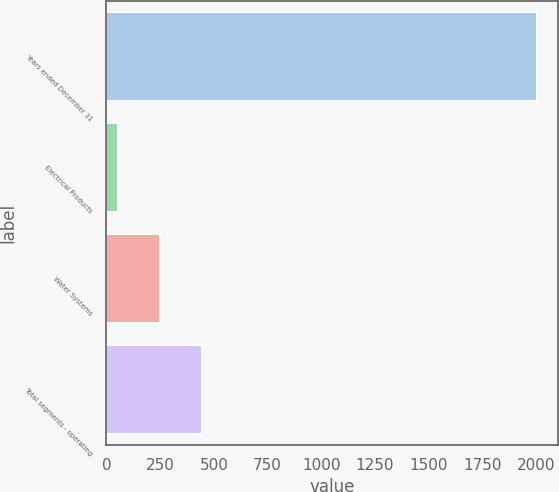Convert chart. <chart><loc_0><loc_0><loc_500><loc_500><bar_chart><fcel>Years ended December 31<fcel>Electrical Products<fcel>Water Systems<fcel>Total segments - operating<nl><fcel>2003<fcel>54.2<fcel>249.08<fcel>443.96<nl></chart> 